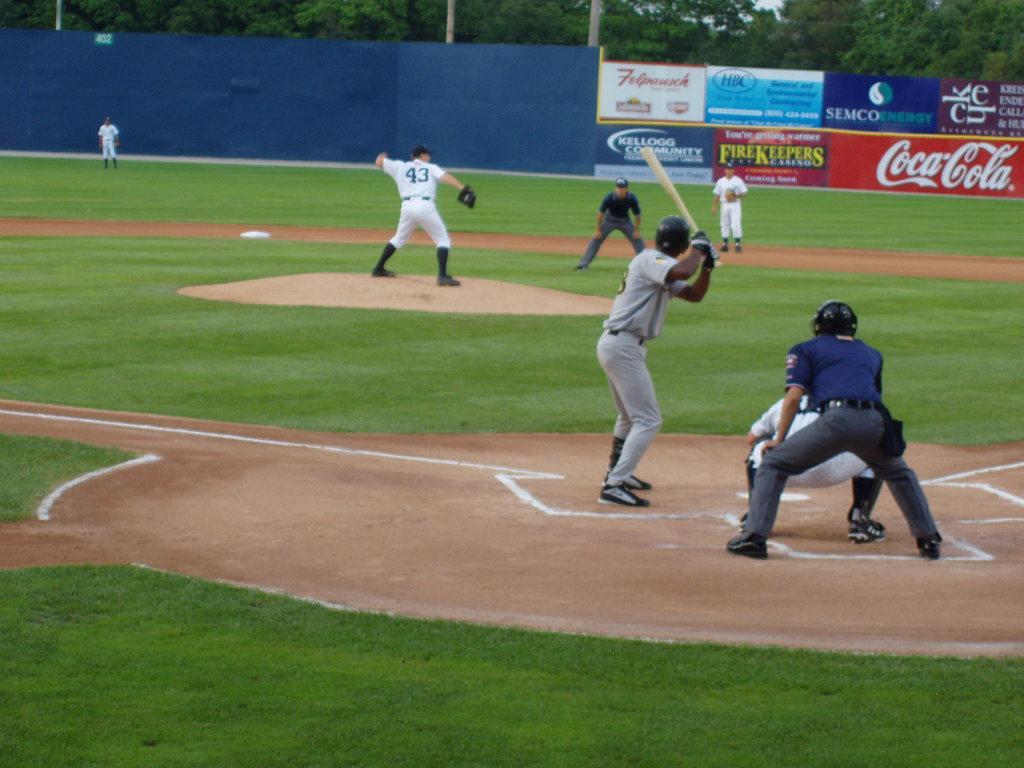In one or two sentences, can you explain what this image depicts? Here in this picture we can see a group of men standing on the ground and we can see they are playing the baseball game, as we can see the person in the front is holding a bat and in front of him we can see another person is ready to throw the ball and some people are wearing gloves, helmet on them and we can see some part of ground is covered with grass and in the far we can see hoardings, banners present and we can also see plants and trees present behind that over there. 